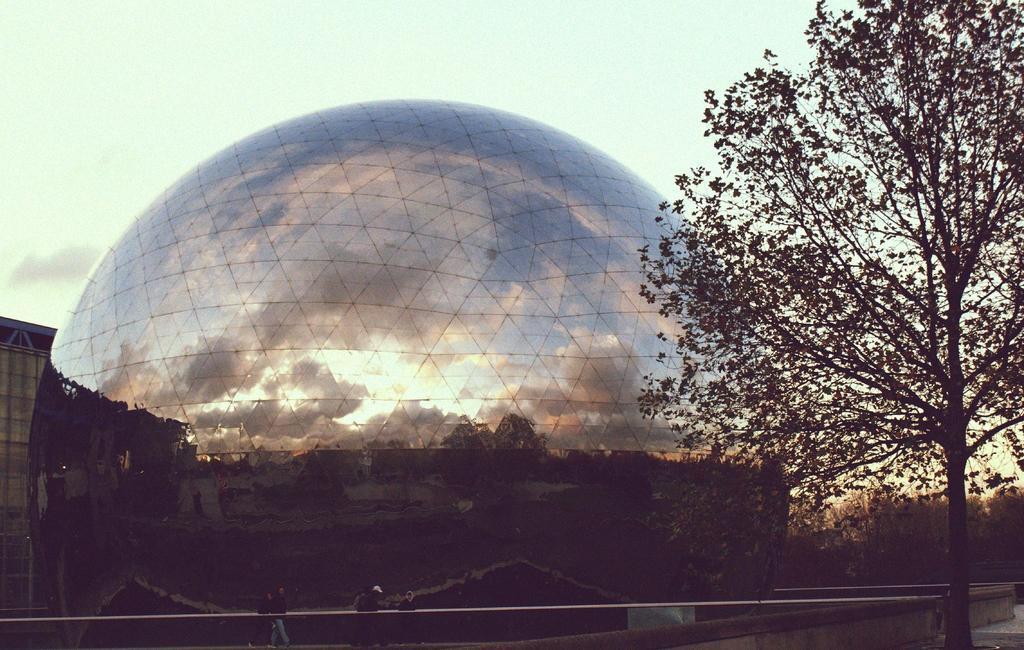Could you give a brief overview of what you see in this image? In the image there is a domed shaped construction with mirror reflection on it, there is a tree on the right side and in the back there are many trees and above its sky. 